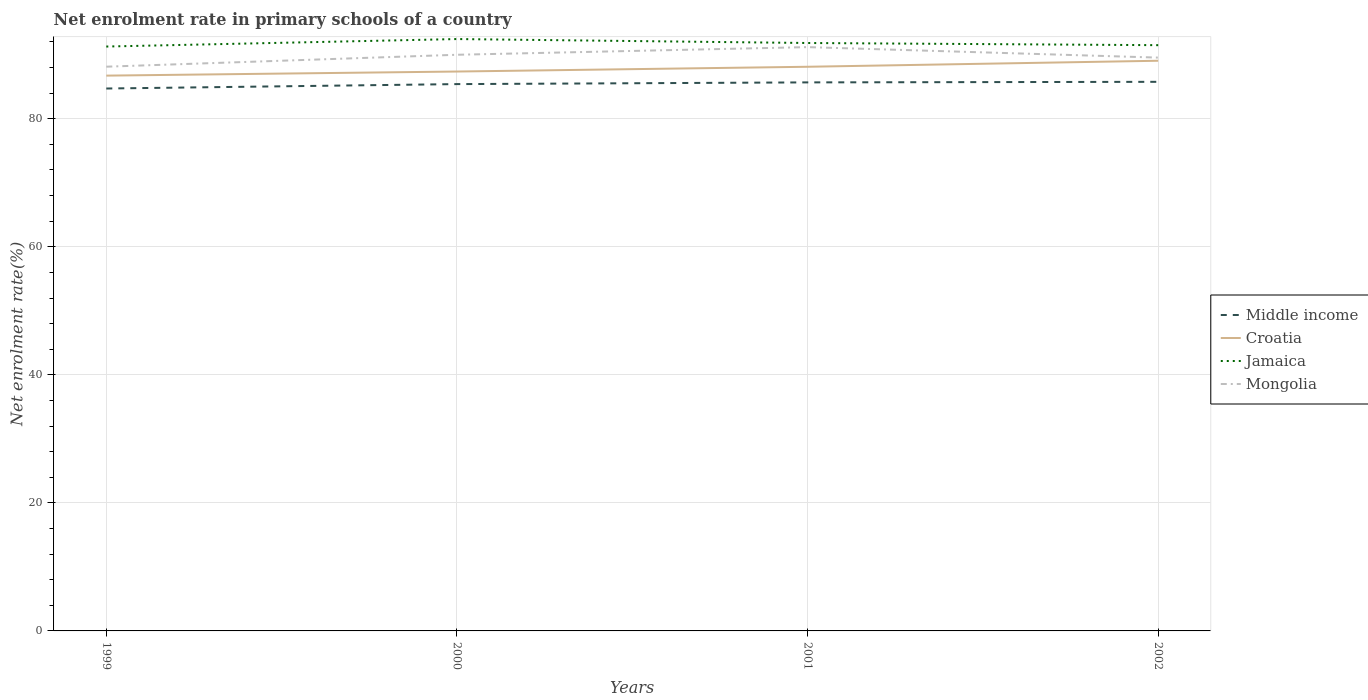Does the line corresponding to Croatia intersect with the line corresponding to Mongolia?
Your answer should be compact. No. Is the number of lines equal to the number of legend labels?
Offer a very short reply. Yes. Across all years, what is the maximum net enrolment rate in primary schools in Mongolia?
Ensure brevity in your answer.  88.13. In which year was the net enrolment rate in primary schools in Mongolia maximum?
Your answer should be very brief. 1999. What is the total net enrolment rate in primary schools in Middle income in the graph?
Your answer should be very brief. -1.05. What is the difference between the highest and the second highest net enrolment rate in primary schools in Jamaica?
Your answer should be compact. 1.17. Is the net enrolment rate in primary schools in Mongolia strictly greater than the net enrolment rate in primary schools in Croatia over the years?
Provide a succinct answer. No. How many years are there in the graph?
Your response must be concise. 4. Are the values on the major ticks of Y-axis written in scientific E-notation?
Ensure brevity in your answer.  No. Does the graph contain any zero values?
Keep it short and to the point. No. Does the graph contain grids?
Provide a short and direct response. Yes. How many legend labels are there?
Give a very brief answer. 4. How are the legend labels stacked?
Make the answer very short. Vertical. What is the title of the graph?
Ensure brevity in your answer.  Net enrolment rate in primary schools of a country. What is the label or title of the X-axis?
Give a very brief answer. Years. What is the label or title of the Y-axis?
Offer a terse response. Net enrolment rate(%). What is the Net enrolment rate(%) of Middle income in 1999?
Give a very brief answer. 84.72. What is the Net enrolment rate(%) of Croatia in 1999?
Provide a succinct answer. 86.74. What is the Net enrolment rate(%) of Jamaica in 1999?
Give a very brief answer. 91.28. What is the Net enrolment rate(%) in Mongolia in 1999?
Offer a terse response. 88.13. What is the Net enrolment rate(%) of Middle income in 2000?
Your response must be concise. 85.41. What is the Net enrolment rate(%) in Croatia in 2000?
Offer a terse response. 87.38. What is the Net enrolment rate(%) of Jamaica in 2000?
Make the answer very short. 92.45. What is the Net enrolment rate(%) in Mongolia in 2000?
Your answer should be compact. 90. What is the Net enrolment rate(%) in Middle income in 2001?
Your response must be concise. 85.68. What is the Net enrolment rate(%) in Croatia in 2001?
Keep it short and to the point. 88.12. What is the Net enrolment rate(%) in Jamaica in 2001?
Your response must be concise. 91.83. What is the Net enrolment rate(%) in Mongolia in 2001?
Ensure brevity in your answer.  91.19. What is the Net enrolment rate(%) in Middle income in 2002?
Your answer should be compact. 85.77. What is the Net enrolment rate(%) of Croatia in 2002?
Keep it short and to the point. 89.06. What is the Net enrolment rate(%) of Jamaica in 2002?
Your response must be concise. 91.49. What is the Net enrolment rate(%) in Mongolia in 2002?
Your answer should be compact. 89.55. Across all years, what is the maximum Net enrolment rate(%) of Middle income?
Offer a terse response. 85.77. Across all years, what is the maximum Net enrolment rate(%) of Croatia?
Give a very brief answer. 89.06. Across all years, what is the maximum Net enrolment rate(%) in Jamaica?
Your answer should be compact. 92.45. Across all years, what is the maximum Net enrolment rate(%) in Mongolia?
Keep it short and to the point. 91.19. Across all years, what is the minimum Net enrolment rate(%) in Middle income?
Ensure brevity in your answer.  84.72. Across all years, what is the minimum Net enrolment rate(%) in Croatia?
Keep it short and to the point. 86.74. Across all years, what is the minimum Net enrolment rate(%) of Jamaica?
Offer a very short reply. 91.28. Across all years, what is the minimum Net enrolment rate(%) of Mongolia?
Your response must be concise. 88.13. What is the total Net enrolment rate(%) in Middle income in the graph?
Offer a terse response. 341.59. What is the total Net enrolment rate(%) of Croatia in the graph?
Ensure brevity in your answer.  351.3. What is the total Net enrolment rate(%) in Jamaica in the graph?
Make the answer very short. 367.06. What is the total Net enrolment rate(%) in Mongolia in the graph?
Your answer should be very brief. 358.87. What is the difference between the Net enrolment rate(%) of Middle income in 1999 and that in 2000?
Your response must be concise. -0.69. What is the difference between the Net enrolment rate(%) of Croatia in 1999 and that in 2000?
Make the answer very short. -0.64. What is the difference between the Net enrolment rate(%) in Jamaica in 1999 and that in 2000?
Ensure brevity in your answer.  -1.17. What is the difference between the Net enrolment rate(%) of Mongolia in 1999 and that in 2000?
Provide a short and direct response. -1.86. What is the difference between the Net enrolment rate(%) in Middle income in 1999 and that in 2001?
Provide a succinct answer. -0.96. What is the difference between the Net enrolment rate(%) in Croatia in 1999 and that in 2001?
Provide a short and direct response. -1.38. What is the difference between the Net enrolment rate(%) of Jamaica in 1999 and that in 2001?
Your answer should be very brief. -0.55. What is the difference between the Net enrolment rate(%) of Mongolia in 1999 and that in 2001?
Provide a succinct answer. -3.06. What is the difference between the Net enrolment rate(%) in Middle income in 1999 and that in 2002?
Keep it short and to the point. -1.05. What is the difference between the Net enrolment rate(%) of Croatia in 1999 and that in 2002?
Your answer should be very brief. -2.32. What is the difference between the Net enrolment rate(%) in Jamaica in 1999 and that in 2002?
Your answer should be very brief. -0.21. What is the difference between the Net enrolment rate(%) of Mongolia in 1999 and that in 2002?
Ensure brevity in your answer.  -1.42. What is the difference between the Net enrolment rate(%) of Middle income in 2000 and that in 2001?
Give a very brief answer. -0.27. What is the difference between the Net enrolment rate(%) in Croatia in 2000 and that in 2001?
Your response must be concise. -0.74. What is the difference between the Net enrolment rate(%) of Jamaica in 2000 and that in 2001?
Offer a very short reply. 0.62. What is the difference between the Net enrolment rate(%) in Mongolia in 2000 and that in 2001?
Provide a short and direct response. -1.2. What is the difference between the Net enrolment rate(%) of Middle income in 2000 and that in 2002?
Provide a succinct answer. -0.36. What is the difference between the Net enrolment rate(%) in Croatia in 2000 and that in 2002?
Ensure brevity in your answer.  -1.68. What is the difference between the Net enrolment rate(%) in Jamaica in 2000 and that in 2002?
Offer a terse response. 0.96. What is the difference between the Net enrolment rate(%) of Mongolia in 2000 and that in 2002?
Provide a short and direct response. 0.44. What is the difference between the Net enrolment rate(%) of Middle income in 2001 and that in 2002?
Make the answer very short. -0.09. What is the difference between the Net enrolment rate(%) in Croatia in 2001 and that in 2002?
Ensure brevity in your answer.  -0.94. What is the difference between the Net enrolment rate(%) of Jamaica in 2001 and that in 2002?
Your response must be concise. 0.34. What is the difference between the Net enrolment rate(%) in Mongolia in 2001 and that in 2002?
Give a very brief answer. 1.64. What is the difference between the Net enrolment rate(%) of Middle income in 1999 and the Net enrolment rate(%) of Croatia in 2000?
Your answer should be compact. -2.65. What is the difference between the Net enrolment rate(%) of Middle income in 1999 and the Net enrolment rate(%) of Jamaica in 2000?
Offer a very short reply. -7.73. What is the difference between the Net enrolment rate(%) of Middle income in 1999 and the Net enrolment rate(%) of Mongolia in 2000?
Your answer should be compact. -5.27. What is the difference between the Net enrolment rate(%) of Croatia in 1999 and the Net enrolment rate(%) of Jamaica in 2000?
Give a very brief answer. -5.71. What is the difference between the Net enrolment rate(%) in Croatia in 1999 and the Net enrolment rate(%) in Mongolia in 2000?
Make the answer very short. -3.26. What is the difference between the Net enrolment rate(%) of Middle income in 1999 and the Net enrolment rate(%) of Croatia in 2001?
Your answer should be compact. -3.4. What is the difference between the Net enrolment rate(%) of Middle income in 1999 and the Net enrolment rate(%) of Jamaica in 2001?
Offer a terse response. -7.11. What is the difference between the Net enrolment rate(%) of Middle income in 1999 and the Net enrolment rate(%) of Mongolia in 2001?
Provide a succinct answer. -6.47. What is the difference between the Net enrolment rate(%) in Croatia in 1999 and the Net enrolment rate(%) in Jamaica in 2001?
Offer a terse response. -5.1. What is the difference between the Net enrolment rate(%) of Croatia in 1999 and the Net enrolment rate(%) of Mongolia in 2001?
Provide a short and direct response. -4.45. What is the difference between the Net enrolment rate(%) of Jamaica in 1999 and the Net enrolment rate(%) of Mongolia in 2001?
Give a very brief answer. 0.09. What is the difference between the Net enrolment rate(%) in Middle income in 1999 and the Net enrolment rate(%) in Croatia in 2002?
Give a very brief answer. -4.34. What is the difference between the Net enrolment rate(%) in Middle income in 1999 and the Net enrolment rate(%) in Jamaica in 2002?
Your answer should be compact. -6.77. What is the difference between the Net enrolment rate(%) in Middle income in 1999 and the Net enrolment rate(%) in Mongolia in 2002?
Offer a terse response. -4.83. What is the difference between the Net enrolment rate(%) in Croatia in 1999 and the Net enrolment rate(%) in Jamaica in 2002?
Offer a terse response. -4.76. What is the difference between the Net enrolment rate(%) of Croatia in 1999 and the Net enrolment rate(%) of Mongolia in 2002?
Your response must be concise. -2.81. What is the difference between the Net enrolment rate(%) in Jamaica in 1999 and the Net enrolment rate(%) in Mongolia in 2002?
Provide a short and direct response. 1.73. What is the difference between the Net enrolment rate(%) of Middle income in 2000 and the Net enrolment rate(%) of Croatia in 2001?
Give a very brief answer. -2.71. What is the difference between the Net enrolment rate(%) in Middle income in 2000 and the Net enrolment rate(%) in Jamaica in 2001?
Ensure brevity in your answer.  -6.42. What is the difference between the Net enrolment rate(%) in Middle income in 2000 and the Net enrolment rate(%) in Mongolia in 2001?
Make the answer very short. -5.78. What is the difference between the Net enrolment rate(%) in Croatia in 2000 and the Net enrolment rate(%) in Jamaica in 2001?
Provide a succinct answer. -4.46. What is the difference between the Net enrolment rate(%) of Croatia in 2000 and the Net enrolment rate(%) of Mongolia in 2001?
Give a very brief answer. -3.81. What is the difference between the Net enrolment rate(%) of Jamaica in 2000 and the Net enrolment rate(%) of Mongolia in 2001?
Provide a short and direct response. 1.26. What is the difference between the Net enrolment rate(%) of Middle income in 2000 and the Net enrolment rate(%) of Croatia in 2002?
Provide a short and direct response. -3.65. What is the difference between the Net enrolment rate(%) of Middle income in 2000 and the Net enrolment rate(%) of Jamaica in 2002?
Offer a terse response. -6.08. What is the difference between the Net enrolment rate(%) of Middle income in 2000 and the Net enrolment rate(%) of Mongolia in 2002?
Provide a short and direct response. -4.14. What is the difference between the Net enrolment rate(%) in Croatia in 2000 and the Net enrolment rate(%) in Jamaica in 2002?
Give a very brief answer. -4.12. What is the difference between the Net enrolment rate(%) of Croatia in 2000 and the Net enrolment rate(%) of Mongolia in 2002?
Provide a short and direct response. -2.17. What is the difference between the Net enrolment rate(%) of Jamaica in 2000 and the Net enrolment rate(%) of Mongolia in 2002?
Ensure brevity in your answer.  2.9. What is the difference between the Net enrolment rate(%) in Middle income in 2001 and the Net enrolment rate(%) in Croatia in 2002?
Your answer should be very brief. -3.38. What is the difference between the Net enrolment rate(%) in Middle income in 2001 and the Net enrolment rate(%) in Jamaica in 2002?
Keep it short and to the point. -5.81. What is the difference between the Net enrolment rate(%) of Middle income in 2001 and the Net enrolment rate(%) of Mongolia in 2002?
Provide a short and direct response. -3.87. What is the difference between the Net enrolment rate(%) in Croatia in 2001 and the Net enrolment rate(%) in Jamaica in 2002?
Keep it short and to the point. -3.37. What is the difference between the Net enrolment rate(%) in Croatia in 2001 and the Net enrolment rate(%) in Mongolia in 2002?
Your answer should be very brief. -1.43. What is the difference between the Net enrolment rate(%) in Jamaica in 2001 and the Net enrolment rate(%) in Mongolia in 2002?
Provide a succinct answer. 2.28. What is the average Net enrolment rate(%) in Middle income per year?
Make the answer very short. 85.4. What is the average Net enrolment rate(%) of Croatia per year?
Give a very brief answer. 87.82. What is the average Net enrolment rate(%) of Jamaica per year?
Your response must be concise. 91.76. What is the average Net enrolment rate(%) of Mongolia per year?
Keep it short and to the point. 89.72. In the year 1999, what is the difference between the Net enrolment rate(%) of Middle income and Net enrolment rate(%) of Croatia?
Give a very brief answer. -2.01. In the year 1999, what is the difference between the Net enrolment rate(%) in Middle income and Net enrolment rate(%) in Jamaica?
Make the answer very short. -6.56. In the year 1999, what is the difference between the Net enrolment rate(%) of Middle income and Net enrolment rate(%) of Mongolia?
Ensure brevity in your answer.  -3.41. In the year 1999, what is the difference between the Net enrolment rate(%) in Croatia and Net enrolment rate(%) in Jamaica?
Make the answer very short. -4.54. In the year 1999, what is the difference between the Net enrolment rate(%) of Croatia and Net enrolment rate(%) of Mongolia?
Your answer should be compact. -1.4. In the year 1999, what is the difference between the Net enrolment rate(%) in Jamaica and Net enrolment rate(%) in Mongolia?
Your answer should be compact. 3.15. In the year 2000, what is the difference between the Net enrolment rate(%) in Middle income and Net enrolment rate(%) in Croatia?
Ensure brevity in your answer.  -1.96. In the year 2000, what is the difference between the Net enrolment rate(%) of Middle income and Net enrolment rate(%) of Jamaica?
Provide a succinct answer. -7.04. In the year 2000, what is the difference between the Net enrolment rate(%) of Middle income and Net enrolment rate(%) of Mongolia?
Offer a terse response. -4.58. In the year 2000, what is the difference between the Net enrolment rate(%) of Croatia and Net enrolment rate(%) of Jamaica?
Provide a short and direct response. -5.07. In the year 2000, what is the difference between the Net enrolment rate(%) in Croatia and Net enrolment rate(%) in Mongolia?
Keep it short and to the point. -2.62. In the year 2000, what is the difference between the Net enrolment rate(%) in Jamaica and Net enrolment rate(%) in Mongolia?
Provide a short and direct response. 2.46. In the year 2001, what is the difference between the Net enrolment rate(%) in Middle income and Net enrolment rate(%) in Croatia?
Offer a terse response. -2.44. In the year 2001, what is the difference between the Net enrolment rate(%) in Middle income and Net enrolment rate(%) in Jamaica?
Provide a succinct answer. -6.15. In the year 2001, what is the difference between the Net enrolment rate(%) in Middle income and Net enrolment rate(%) in Mongolia?
Make the answer very short. -5.51. In the year 2001, what is the difference between the Net enrolment rate(%) of Croatia and Net enrolment rate(%) of Jamaica?
Ensure brevity in your answer.  -3.71. In the year 2001, what is the difference between the Net enrolment rate(%) of Croatia and Net enrolment rate(%) of Mongolia?
Make the answer very short. -3.07. In the year 2001, what is the difference between the Net enrolment rate(%) of Jamaica and Net enrolment rate(%) of Mongolia?
Make the answer very short. 0.64. In the year 2002, what is the difference between the Net enrolment rate(%) of Middle income and Net enrolment rate(%) of Croatia?
Make the answer very short. -3.29. In the year 2002, what is the difference between the Net enrolment rate(%) of Middle income and Net enrolment rate(%) of Jamaica?
Provide a short and direct response. -5.73. In the year 2002, what is the difference between the Net enrolment rate(%) in Middle income and Net enrolment rate(%) in Mongolia?
Your answer should be very brief. -3.78. In the year 2002, what is the difference between the Net enrolment rate(%) in Croatia and Net enrolment rate(%) in Jamaica?
Offer a terse response. -2.44. In the year 2002, what is the difference between the Net enrolment rate(%) of Croatia and Net enrolment rate(%) of Mongolia?
Make the answer very short. -0.49. In the year 2002, what is the difference between the Net enrolment rate(%) in Jamaica and Net enrolment rate(%) in Mongolia?
Ensure brevity in your answer.  1.94. What is the ratio of the Net enrolment rate(%) of Jamaica in 1999 to that in 2000?
Give a very brief answer. 0.99. What is the ratio of the Net enrolment rate(%) in Mongolia in 1999 to that in 2000?
Provide a short and direct response. 0.98. What is the ratio of the Net enrolment rate(%) in Croatia in 1999 to that in 2001?
Ensure brevity in your answer.  0.98. What is the ratio of the Net enrolment rate(%) in Mongolia in 1999 to that in 2001?
Give a very brief answer. 0.97. What is the ratio of the Net enrolment rate(%) in Middle income in 1999 to that in 2002?
Your response must be concise. 0.99. What is the ratio of the Net enrolment rate(%) in Croatia in 1999 to that in 2002?
Your answer should be very brief. 0.97. What is the ratio of the Net enrolment rate(%) of Jamaica in 1999 to that in 2002?
Your answer should be very brief. 1. What is the ratio of the Net enrolment rate(%) in Mongolia in 1999 to that in 2002?
Make the answer very short. 0.98. What is the ratio of the Net enrolment rate(%) in Middle income in 2000 to that in 2001?
Keep it short and to the point. 1. What is the ratio of the Net enrolment rate(%) of Mongolia in 2000 to that in 2001?
Make the answer very short. 0.99. What is the ratio of the Net enrolment rate(%) in Croatia in 2000 to that in 2002?
Ensure brevity in your answer.  0.98. What is the ratio of the Net enrolment rate(%) of Jamaica in 2000 to that in 2002?
Offer a very short reply. 1.01. What is the ratio of the Net enrolment rate(%) of Middle income in 2001 to that in 2002?
Keep it short and to the point. 1. What is the ratio of the Net enrolment rate(%) of Mongolia in 2001 to that in 2002?
Make the answer very short. 1.02. What is the difference between the highest and the second highest Net enrolment rate(%) in Middle income?
Offer a terse response. 0.09. What is the difference between the highest and the second highest Net enrolment rate(%) in Croatia?
Offer a very short reply. 0.94. What is the difference between the highest and the second highest Net enrolment rate(%) in Jamaica?
Your response must be concise. 0.62. What is the difference between the highest and the second highest Net enrolment rate(%) in Mongolia?
Ensure brevity in your answer.  1.2. What is the difference between the highest and the lowest Net enrolment rate(%) in Middle income?
Provide a short and direct response. 1.05. What is the difference between the highest and the lowest Net enrolment rate(%) in Croatia?
Offer a terse response. 2.32. What is the difference between the highest and the lowest Net enrolment rate(%) in Jamaica?
Give a very brief answer. 1.17. What is the difference between the highest and the lowest Net enrolment rate(%) in Mongolia?
Provide a succinct answer. 3.06. 